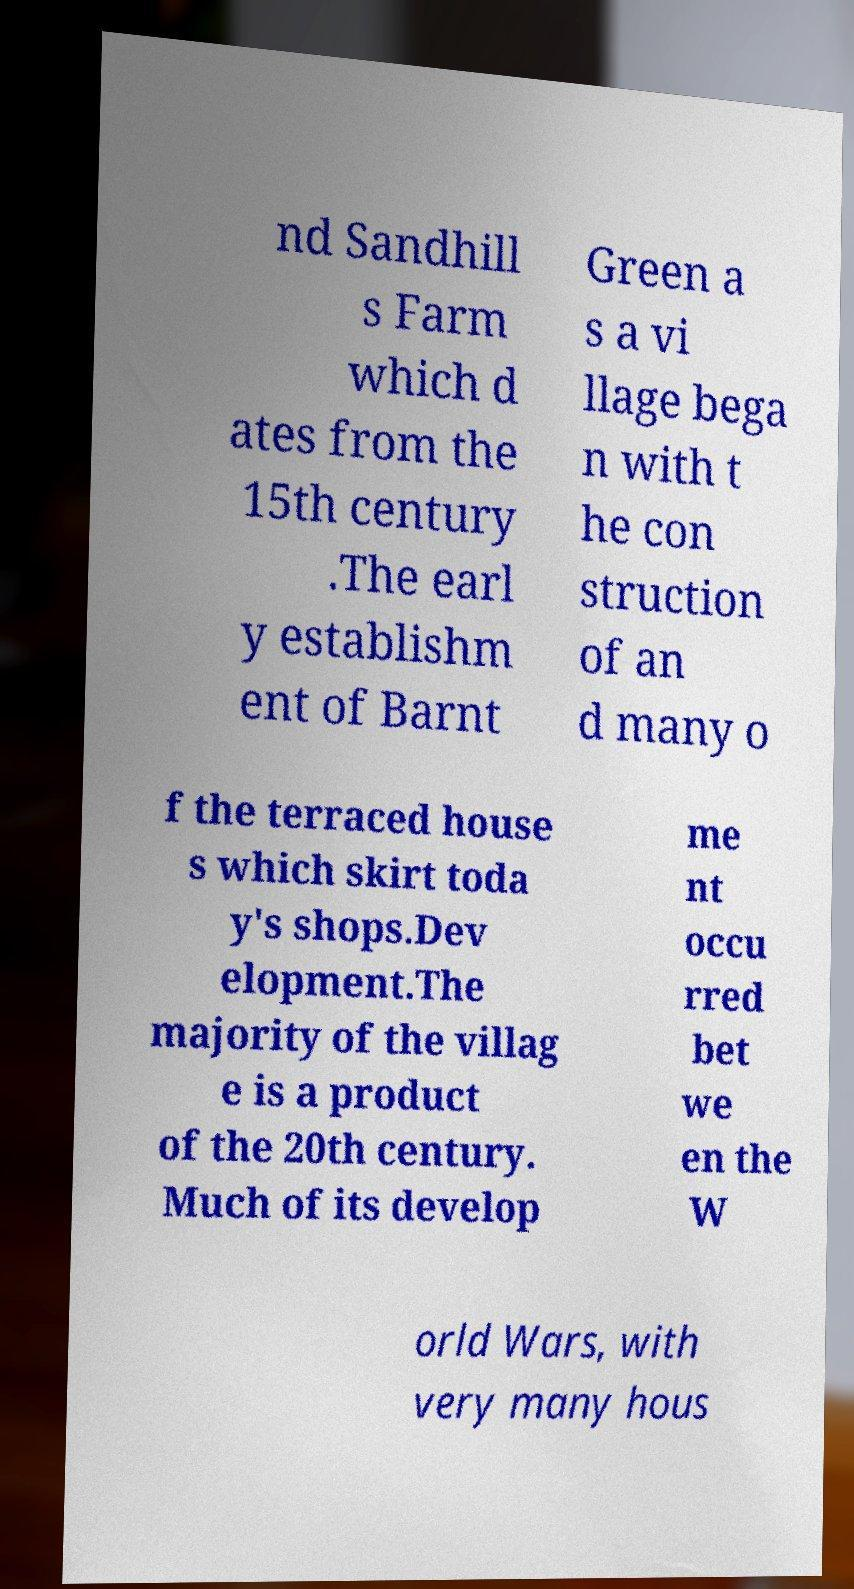For documentation purposes, I need the text within this image transcribed. Could you provide that? nd Sandhill s Farm which d ates from the 15th century .The earl y establishm ent of Barnt Green a s a vi llage bega n with t he con struction of an d many o f the terraced house s which skirt toda y's shops.Dev elopment.The majority of the villag e is a product of the 20th century. Much of its develop me nt occu rred bet we en the W orld Wars, with very many hous 